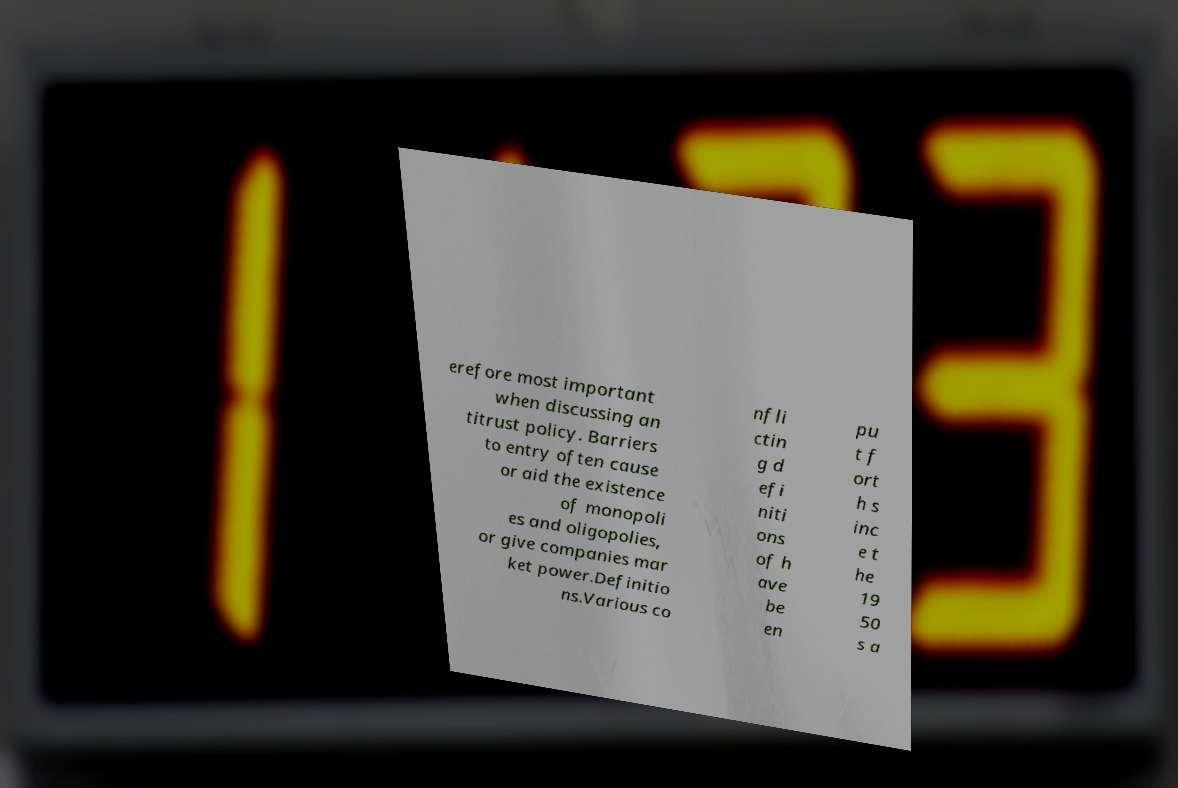Can you accurately transcribe the text from the provided image for me? erefore most important when discussing an titrust policy. Barriers to entry often cause or aid the existence of monopoli es and oligopolies, or give companies mar ket power.Definitio ns.Various co nfli ctin g d efi niti ons of h ave be en pu t f ort h s inc e t he 19 50 s a 